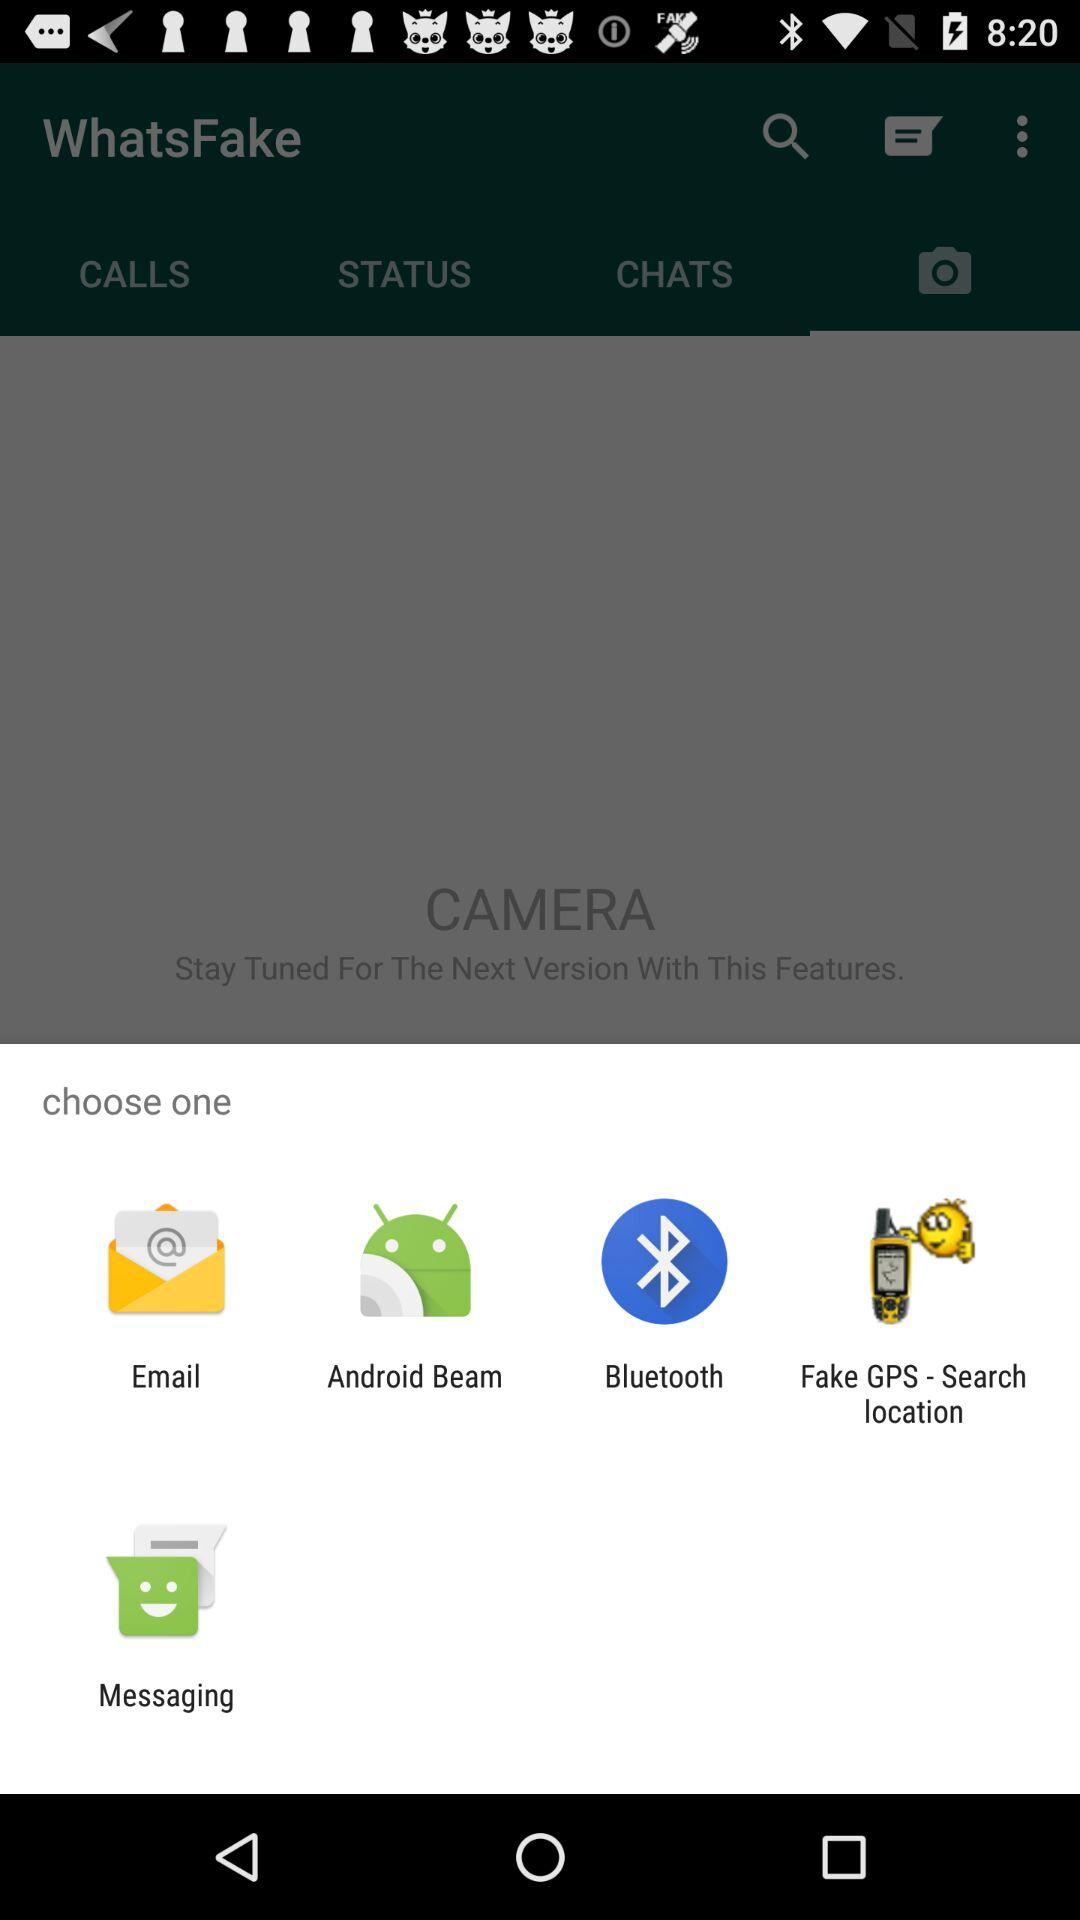What is the name of the application? The name of the application is "WhatsFake". 